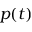Convert formula to latex. <formula><loc_0><loc_0><loc_500><loc_500>p ( t )</formula> 